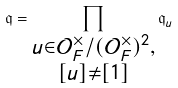Convert formula to latex. <formula><loc_0><loc_0><loc_500><loc_500>\mathfrak { q } = \prod _ { \substack { u \in \mathcal { O } _ { F } ^ { \times } / ( \mathcal { O } _ { F } ^ { \times } ) ^ { 2 } , \\ [ u ] \neq [ 1 ] } } \mathfrak { q } _ { u }</formula> 